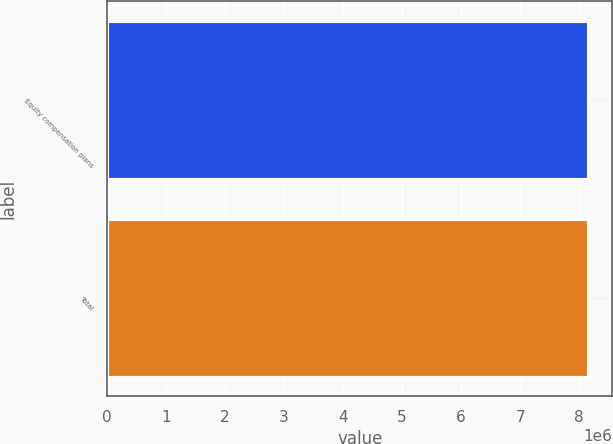<chart> <loc_0><loc_0><loc_500><loc_500><bar_chart><fcel>Equity compensation plans<fcel>Total<nl><fcel>8.15444e+06<fcel>8.15444e+06<nl></chart> 